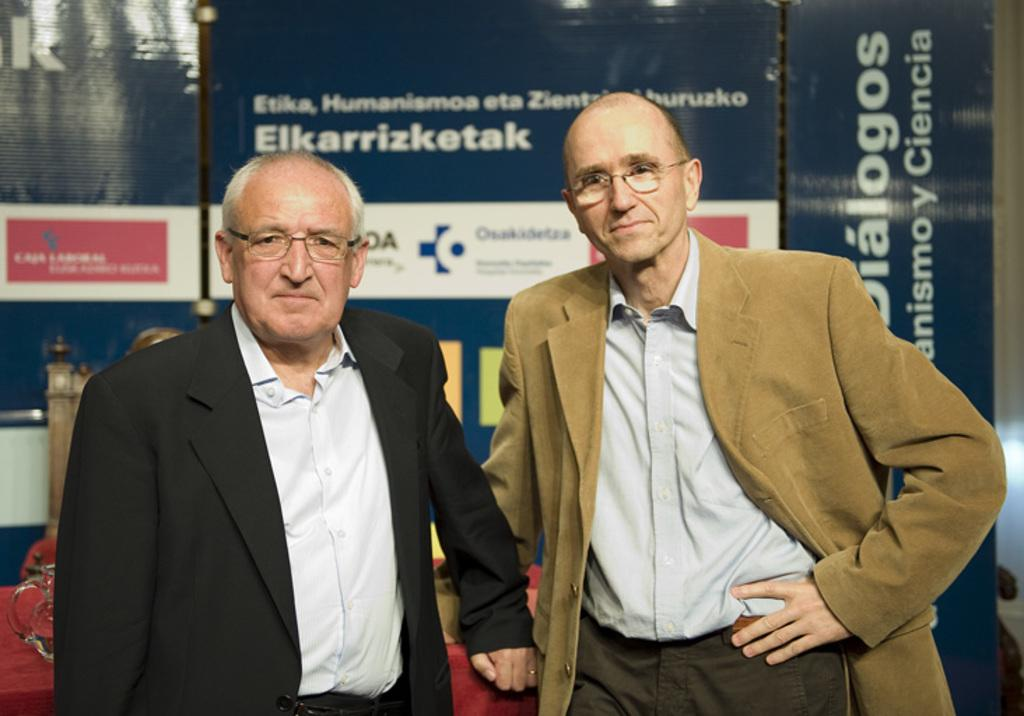How many men are in the image? There are two men standing in the front of the image. What are the men wearing? The men are wearing spectacles. What can be seen in the background of the image? There are words visible in the background of the image, and there is text present on boards. Which leg is the man on the left using to kick the button in the image? There is no man kicking a button in the image; the men are wearing spectacles and standing still. What type of fiction is the man on the right reading in the image? There is no fiction or reading material present in the image; the men are simply standing and wearing spectacles. 